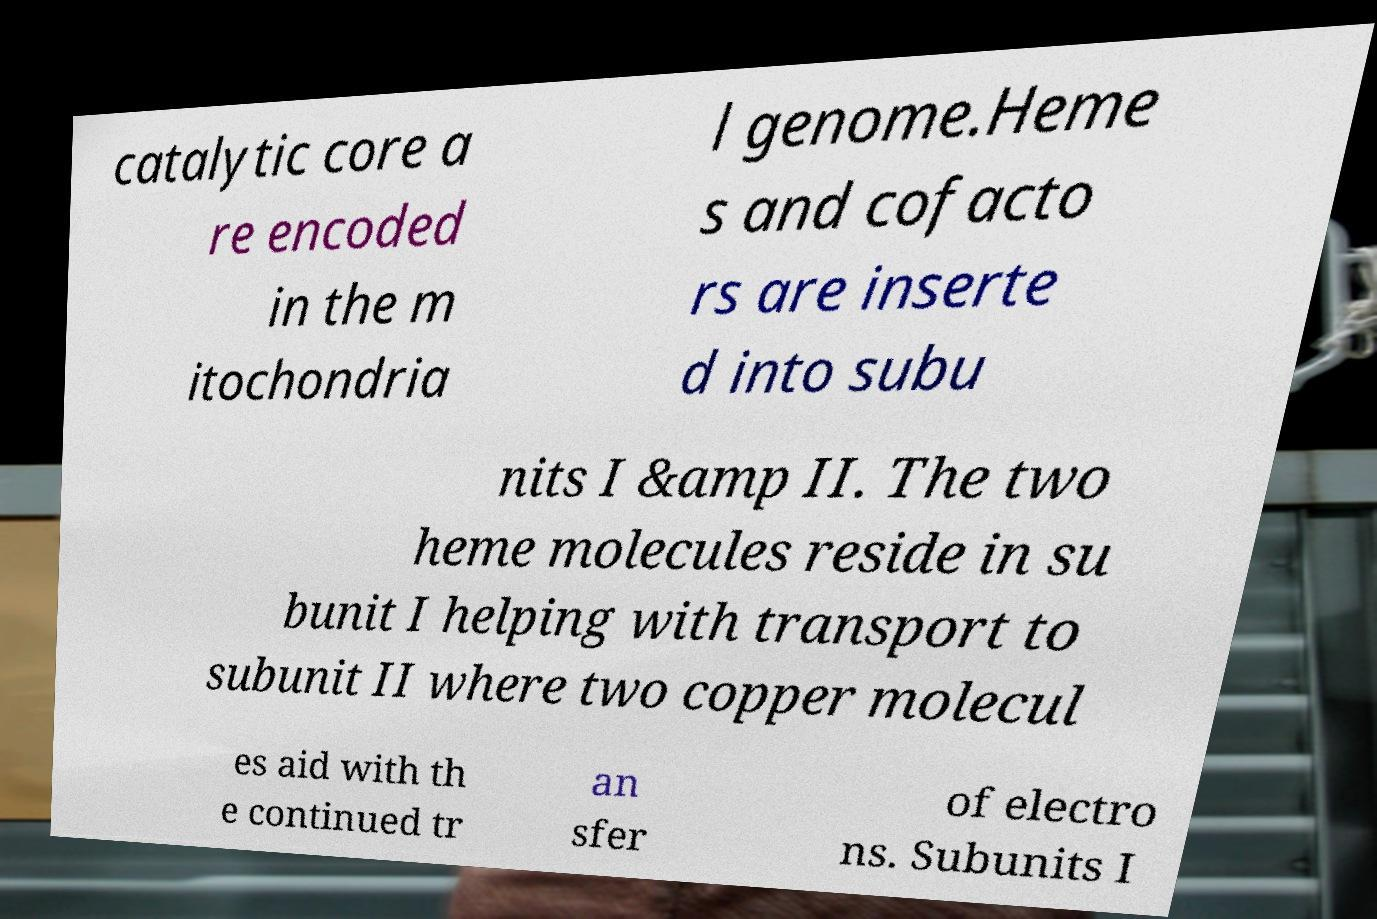Could you assist in decoding the text presented in this image and type it out clearly? catalytic core a re encoded in the m itochondria l genome.Heme s and cofacto rs are inserte d into subu nits I &amp II. The two heme molecules reside in su bunit I helping with transport to subunit II where two copper molecul es aid with th e continued tr an sfer of electro ns. Subunits I 